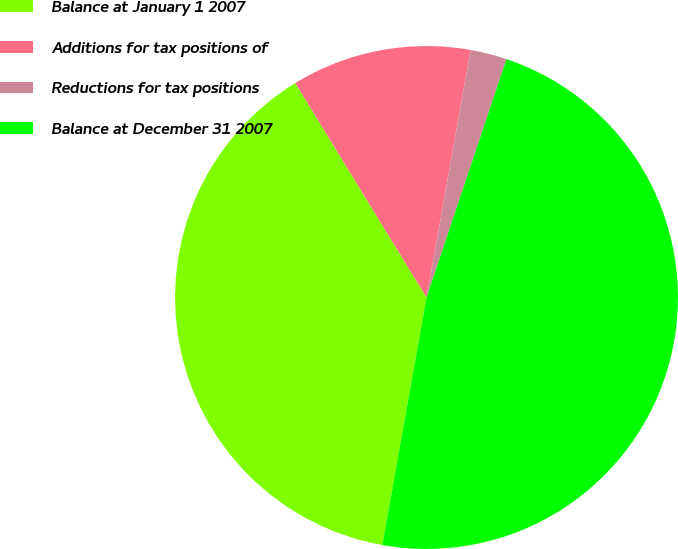<chart> <loc_0><loc_0><loc_500><loc_500><pie_chart><fcel>Balance at January 1 2007<fcel>Additions for tax positions of<fcel>Reductions for tax positions<fcel>Balance at December 31 2007<nl><fcel>38.45%<fcel>11.55%<fcel>2.34%<fcel>47.66%<nl></chart> 